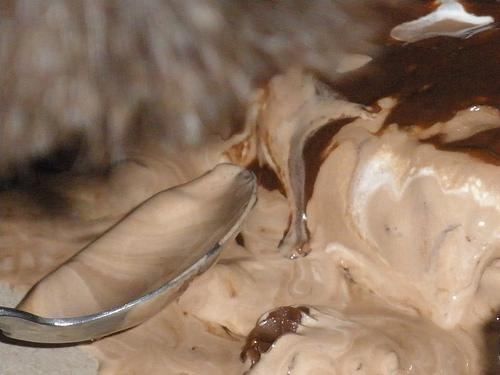In a concise manner, state the main object in the image and what it is surrounded by or covered in. A spoon covered in creamy chocolate dessert with swirls of vanilla. Mention the type of dessert and its connection to the main object in the image. Melted chocolate and vanilla ice cream on a metal spoon. Point out the appearance and position of the dessert in the image. Brown ice cream oozing and melting is on the spoon. Describe the dessert's characteristics and its relation to the object in the image. Sweet brown ice cream is melting and oozing on a silver spoon. Mention the central object in the image and its color or material. A silver metal spoon is prominently featured in the image. Point out the main elements of the image and their visual characteristics. A silver metallic spoon holds chocolate ice cream swirled with vanilla, both melting. Describe the interaction between the utensil and the dessert in the image. The metal spoon is holding melted swirled ice cream, including chocolate and vanilla flavors. Briefly state what the image depicts and its main components. The image shows a silver spoon covered in melting chocolate and vanilla ice cream. What is the primary focus of the image and what is happening to the dessert? The main focus is a spoon, which has melting ice cream with swirls of chocolate and vanilla. Write a simple description of the image with two key elements. A metallic spoon holds some melting chocolate and vanilla ice cream. Can you see any green vegetables in the ice cream? The image does not describe any green vegetables in the ice cream. Notice the addition of nuts and caramel in the ice cream. The image does not describe any nuts or caramel in the ice cream. Point to the area where the syrup is cold and chunky. The syrup is described as being hot fudge and smooth, not cold and chunky. Identify the yellow custard covering the spoon. The spoon is covered in chocolate ice cream and cream, not yellow custard. Can you see an entirely pink spoon hidden within the cream? The spoon is not described as being pink or hidden; it is silver and visible in the image. Find the square-shaped section of the chocolate and point it out. The chocolate is not described as having a square-shaped section in the image. Is the spoon made of plastic and green in color? The spoon is described as metallic and silver in the image, not plastic and green. Is the ice cream in the image blue and tastes like bubblegum? The ice cream is described as brown, chocolate, and vanilla, not blue and bubblegum-flavored. Is there a bright red cherry on top of the ice cream? The image does not mention a bright red cherry as a part of the ice cream. Find a fork instead of a spoon in the image. The image only contains a spoon, not a fork. 